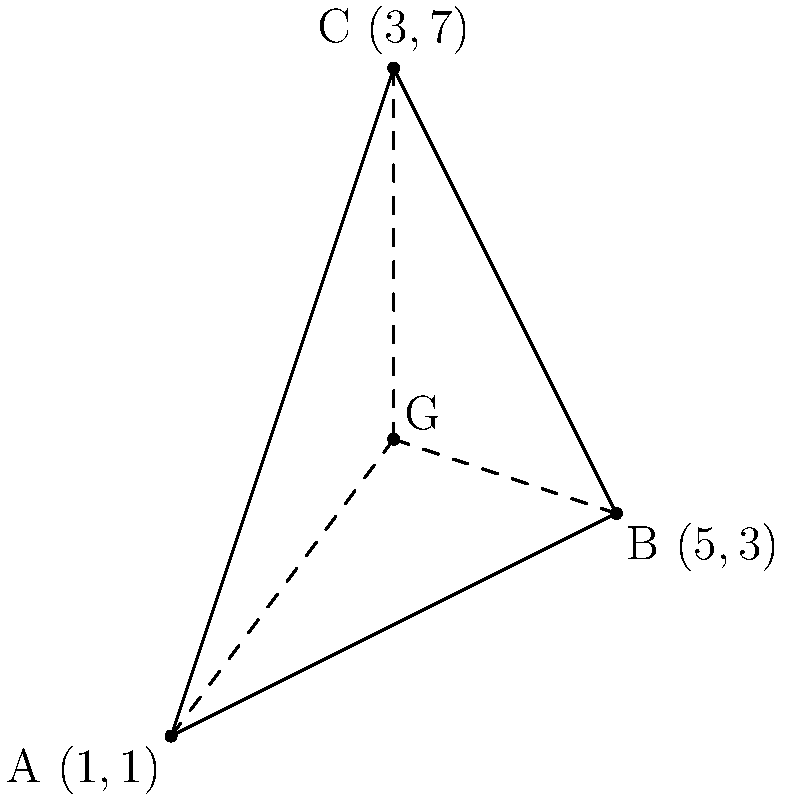As a fellow illustrator, you're working on a geometric composition. Given a triangle with vertices A(1,1), B(5,3), and C(3,7), find the coordinates of the centroid (G) of this triangle. How might this point be useful in balancing your illustration? To find the centroid of a triangle, we can follow these steps:

1) The centroid of a triangle is located at the intersection of its medians. It divides each median in a 2:1 ratio, closer to the midpoint of a side.

2) The coordinates of the centroid can be calculated using the formula:

   $G_x = \frac{x_A + x_B + x_C}{3}$ and $G_y = \frac{y_A + y_B + y_C}{3}$

   Where $(x_A, y_A)$, $(x_B, y_B)$, and $(x_C, y_C)$ are the coordinates of the triangle's vertices.

3) Let's substitute the given coordinates:

   $G_x = \frac{1 + 5 + 3}{3} = \frac{9}{3} = 3$

   $G_y = \frac{1 + 3 + 7}{3} = \frac{11}{3} \approx 3.67$

4) Therefore, the coordinates of the centroid G are (3, 11/3).

In illustration, the centroid can be a crucial point for balancing composition. It represents the visual center of the triangle, which can be used to create symmetry or to strategically place focal elements in your design.
Answer: $(3, \frac{11}{3})$ 